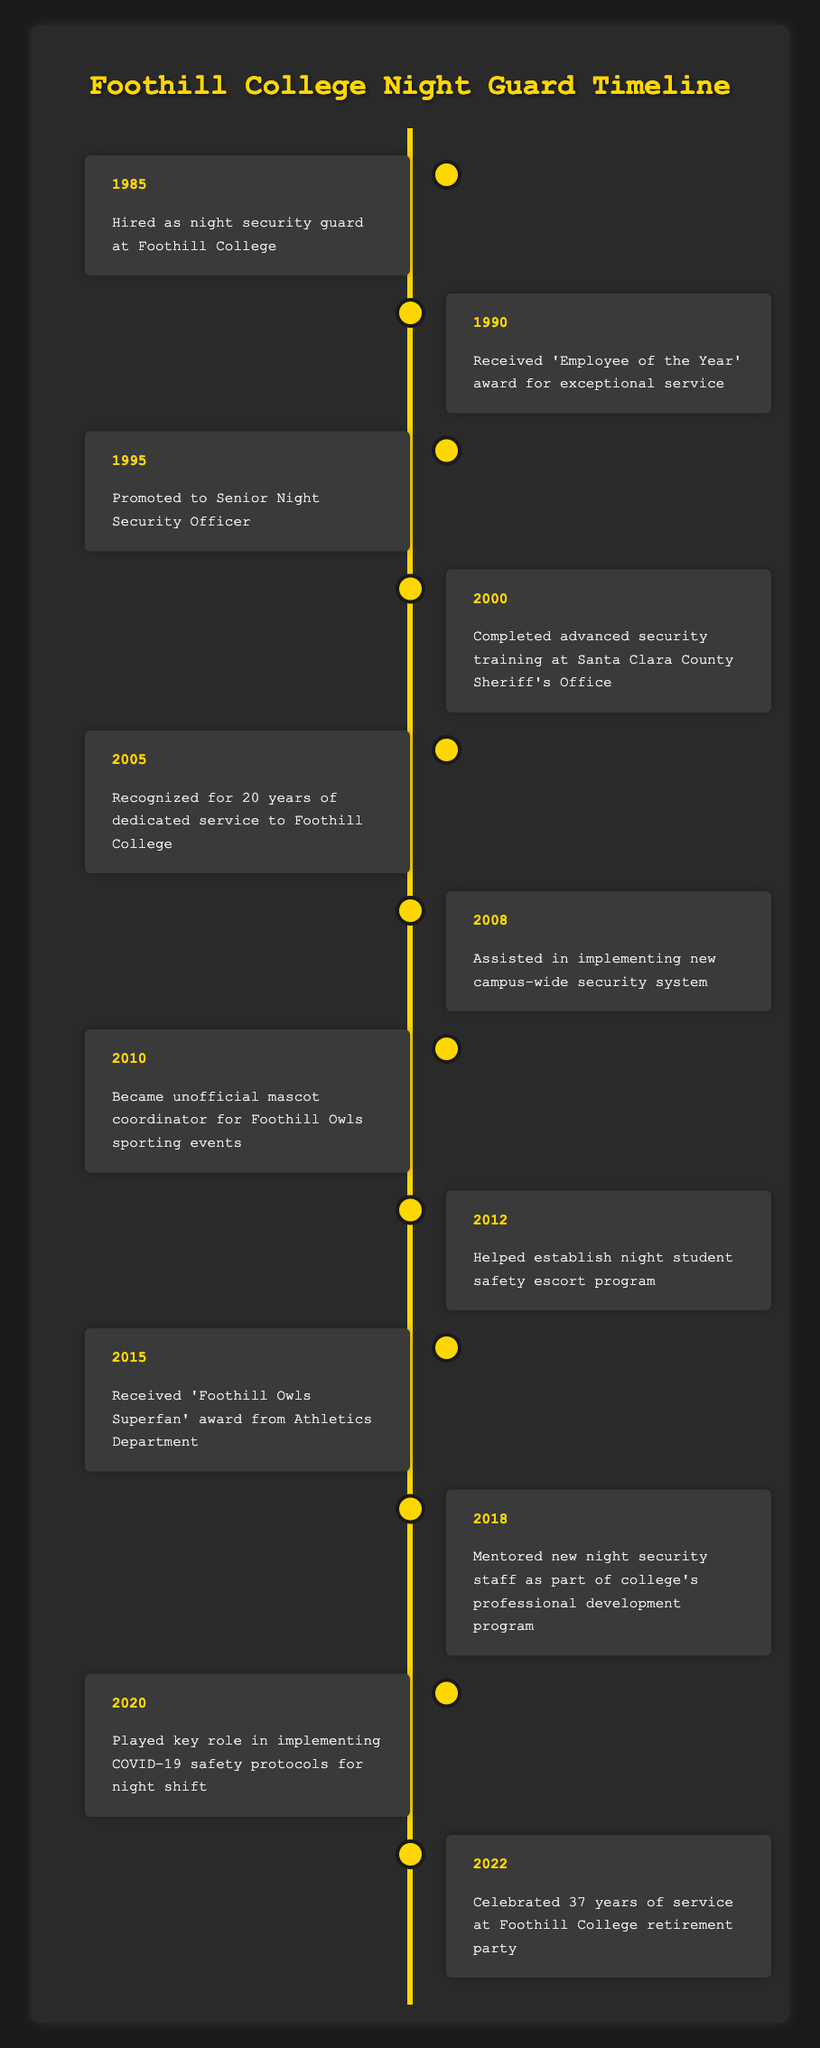What year was the night security guard hired at Foothill College? The table has a row for the year 1985, which states that the security guard was hired in that year.
Answer: 1985 What milestone happened in 1990? Referring to the event listed under the year 1990, it states that the security guard received the "Employee of the Year" award for exceptional service.
Answer: Received 'Employee of the Year' award for exceptional service How many years of service were recognized in 2005? To find this, we refer to the event of the year 2005, which notes that the security guard was recognized for 20 years of dedicated service to Foothill College.
Answer: 20 years What was the final milestone celebrated before retirement? The table shows that in 2022, the security guard celebrated 37 years of service at a retirement party, making it the final milestone before retirement.
Answer: Celebrated 37 years of service at retirement party Did the security guard become an unofficial mascot coordinator? Yes, the table mentions an event in 2010 where the security guard became the unofficial mascot coordinator for Foothill Owls sporting events.
Answer: Yes In what year did the security guard mentor new staff? According to the table, mentoring of new night security staff occurred in 2018.
Answer: 2018 What significant event occurred between 2000 and 2010? Analyzing the entries between 2000 and 2010, we see that in 2008, the security guard assisted in implementing a new campus-wide security system.
Answer: Assisted in implementing new campus-wide security system What event marks an award received related to being a fan? The event listed for the year 2015 states that the security guard received the "Foothill Owls Superfan" award from the Athletics Department.
Answer: Received 'Foothill Owls Superfan' award How many milestones occurred in the 2010s decade? The milestones from the years 2010 to 2019 include three events: 2010, 2012, and 2015, leading to a total of three milestones during this decade.
Answer: 3 milestones What was the time span between being hired and celebrating 37 years of service? The security guard was hired in 1985 and celebrated 37 years of service in 2022. The years are determined by subtracting 1985 from 2022, resulting in a span of 37 years.
Answer: 37 years 